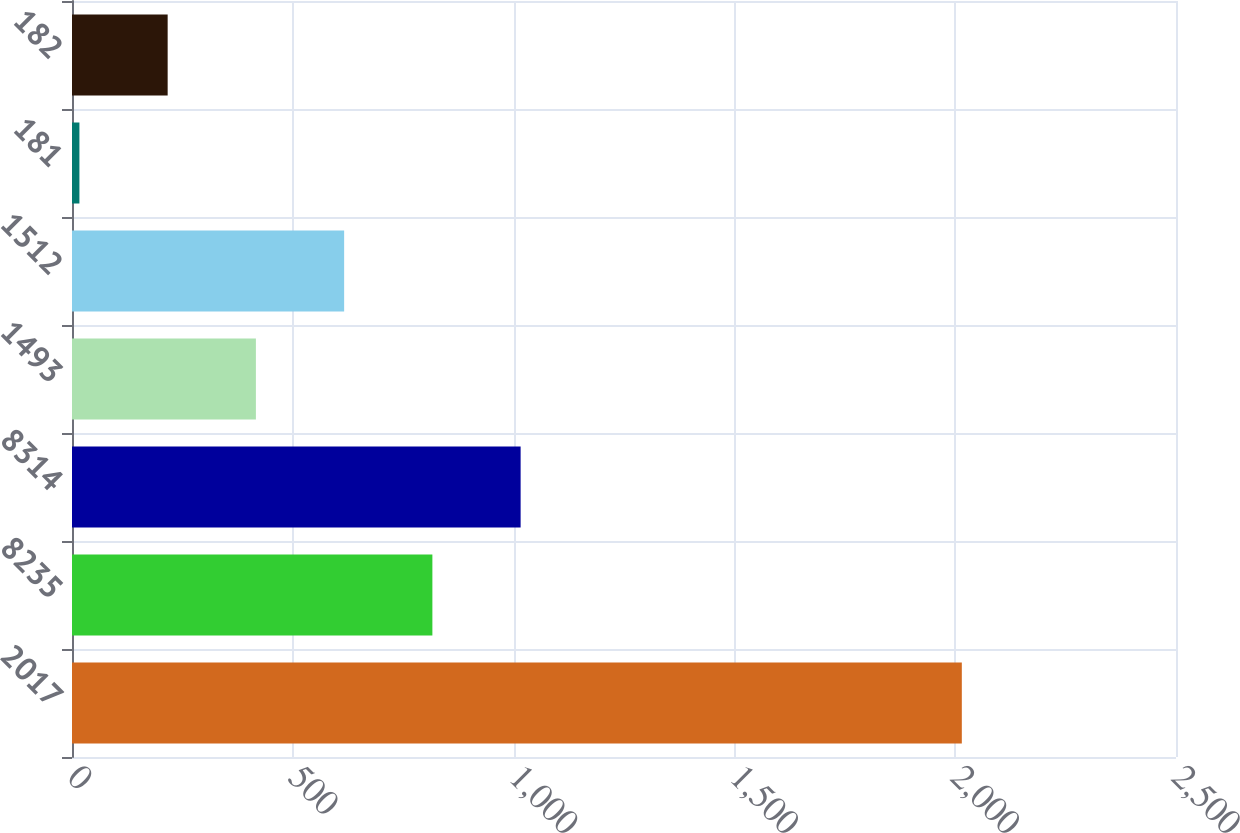Convert chart. <chart><loc_0><loc_0><loc_500><loc_500><bar_chart><fcel>2017<fcel>8235<fcel>8314<fcel>1493<fcel>1512<fcel>181<fcel>182<nl><fcel>2015<fcel>816.08<fcel>1015.9<fcel>416.44<fcel>616.26<fcel>16.8<fcel>216.62<nl></chart> 